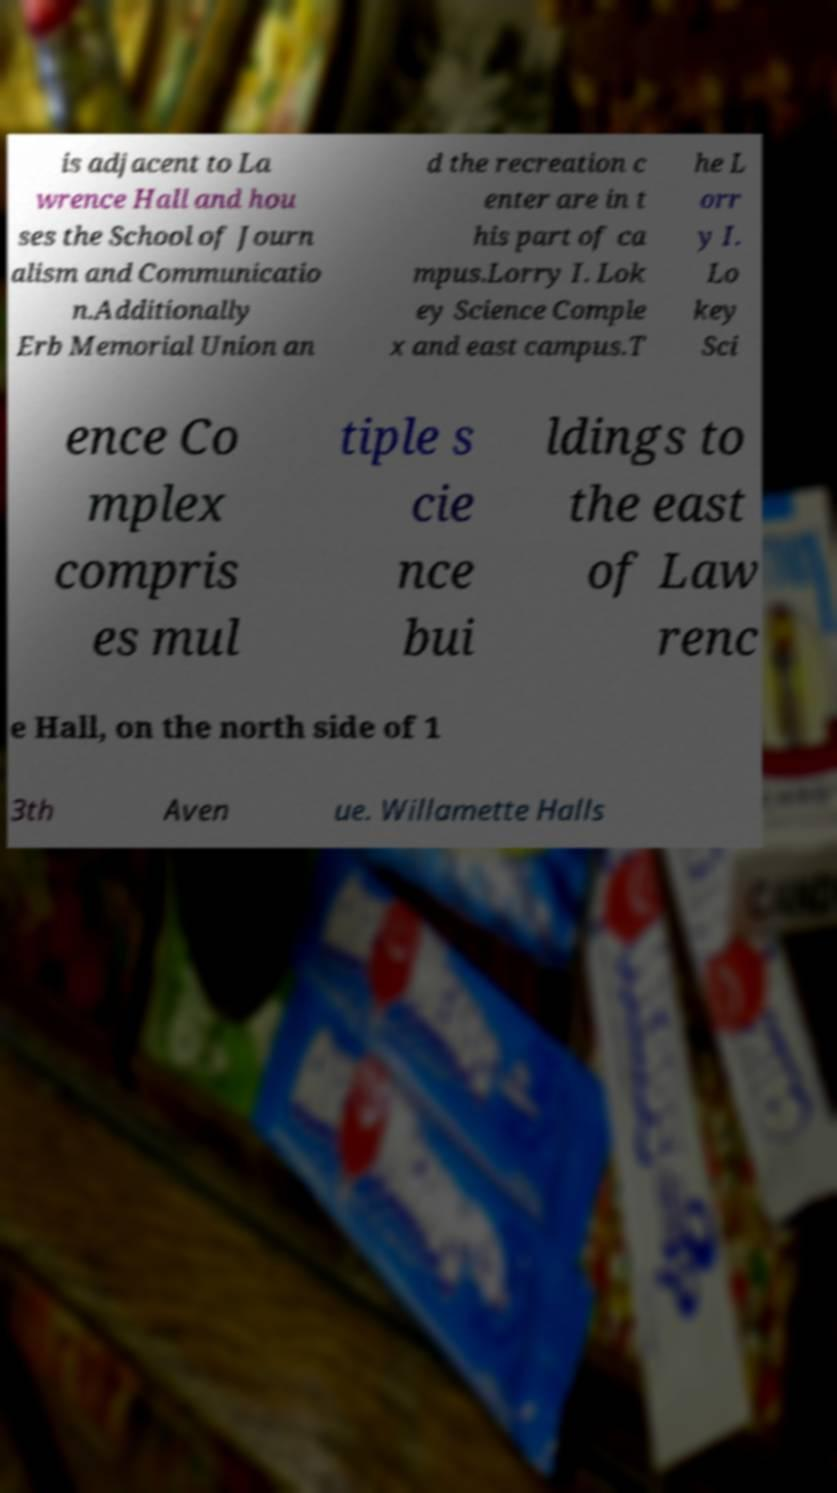Can you accurately transcribe the text from the provided image for me? is adjacent to La wrence Hall and hou ses the School of Journ alism and Communicatio n.Additionally Erb Memorial Union an d the recreation c enter are in t his part of ca mpus.Lorry I. Lok ey Science Comple x and east campus.T he L orr y I. Lo key Sci ence Co mplex compris es mul tiple s cie nce bui ldings to the east of Law renc e Hall, on the north side of 1 3th Aven ue. Willamette Halls 